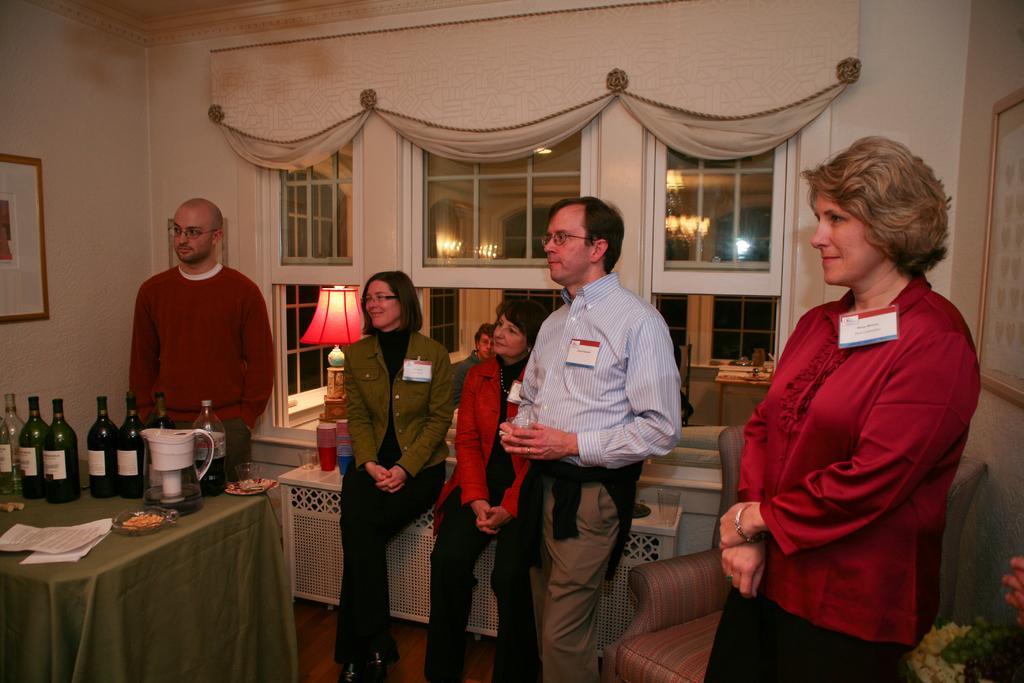In one or two sentences, can you explain what this image depicts? This image is taken indoors. In the background there is a wall with windows and curtains and there is a picture frame. On the left side of the image there is a table with a tablecloth and many things on it and a man is standing on the floor. In the middle of the image a man and two women are there and there is a table with a lamp and a few things on it. On the right side of the image there is a flower vase and a couch and a woman is standing on the floor. 